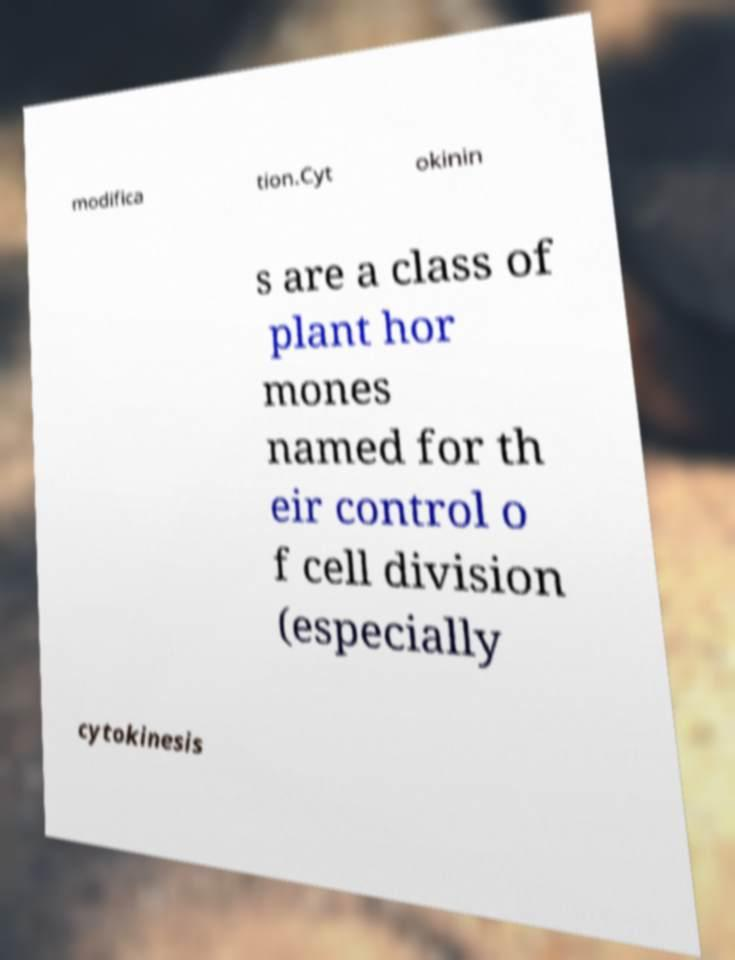There's text embedded in this image that I need extracted. Can you transcribe it verbatim? modifica tion.Cyt okinin s are a class of plant hor mones named for th eir control o f cell division (especially cytokinesis 